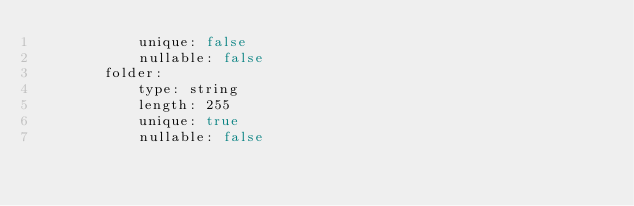<code> <loc_0><loc_0><loc_500><loc_500><_YAML_>            unique: false
            nullable: false
        folder:
            type: string
            length: 255
            unique: true
            nullable: false
</code> 